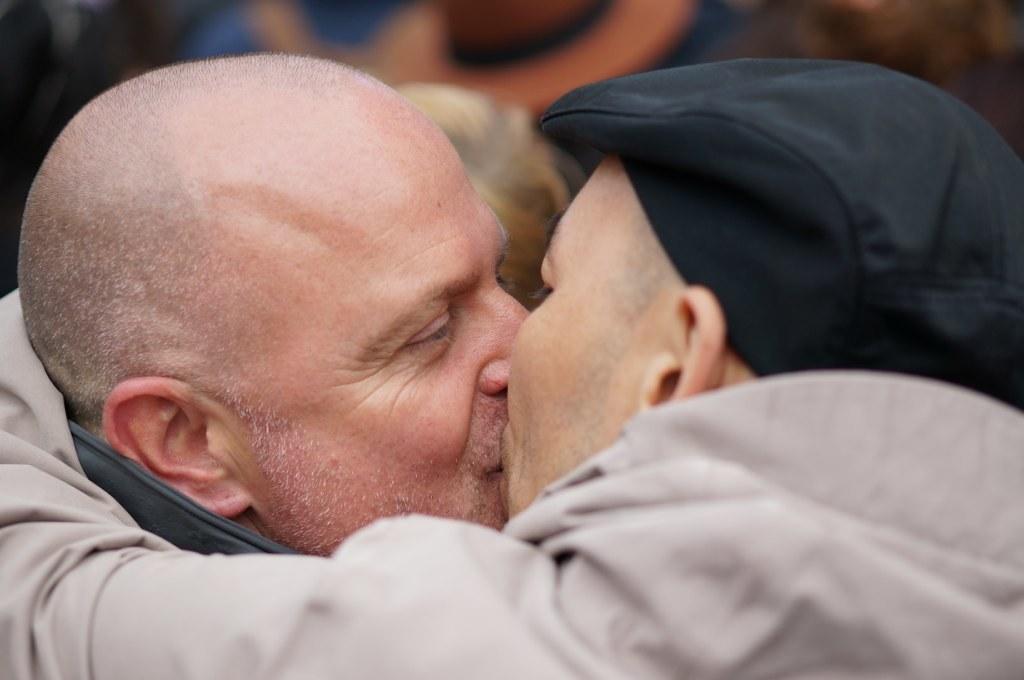In one or two sentences, can you explain what this image depicts? Background portion of the picture is blurred. In this picture we can see men kissing each other. 